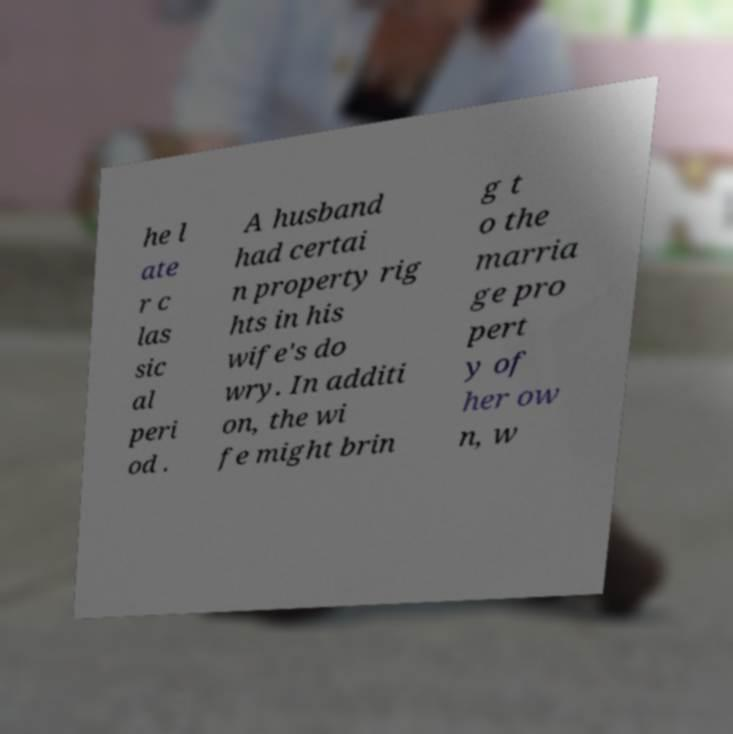Could you extract and type out the text from this image? he l ate r c las sic al peri od . A husband had certai n property rig hts in his wife's do wry. In additi on, the wi fe might brin g t o the marria ge pro pert y of her ow n, w 